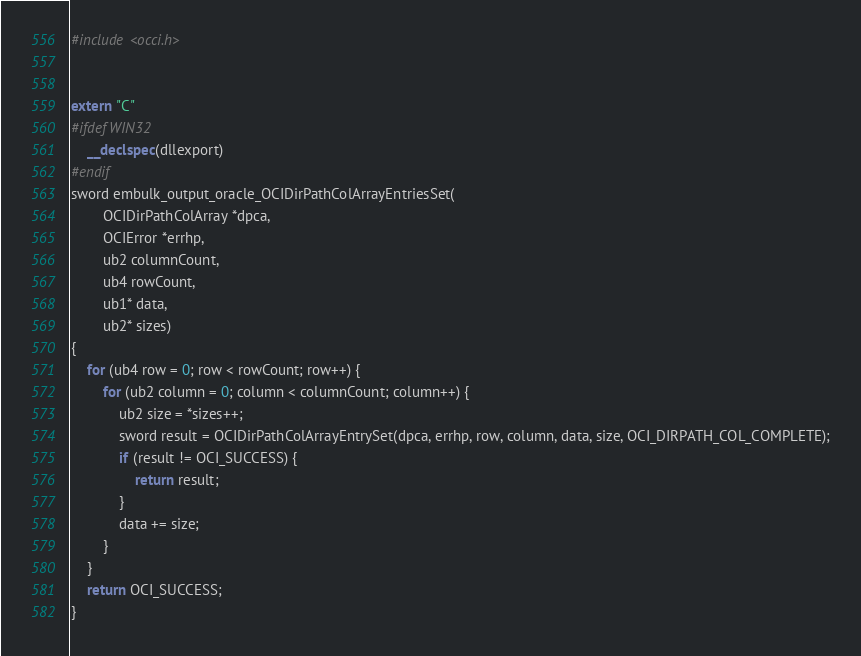Convert code to text. <code><loc_0><loc_0><loc_500><loc_500><_C++_>#include <occi.h>


extern "C" 
#ifdef WIN32
    __declspec(dllexport) 
#endif 
sword embulk_output_oracle_OCIDirPathColArrayEntriesSet(
        OCIDirPathColArray *dpca,
        OCIError *errhp,
        ub2 columnCount,
        ub4 rowCount,
        ub1* data,
        ub2* sizes)
{
    for (ub4 row = 0; row < rowCount; row++) {
        for (ub2 column = 0; column < columnCount; column++) {
            ub2 size = *sizes++;
            sword result = OCIDirPathColArrayEntrySet(dpca, errhp, row, column, data, size, OCI_DIRPATH_COL_COMPLETE);
            if (result != OCI_SUCCESS) {
                return result;
            }
            data += size;
        }
    }
    return OCI_SUCCESS;
}
</code> 